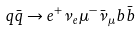<formula> <loc_0><loc_0><loc_500><loc_500>q \bar { q } \to e ^ { + } \nu _ { e } \mu ^ { - } \bar { \nu } _ { \mu } b \bar { b }</formula> 